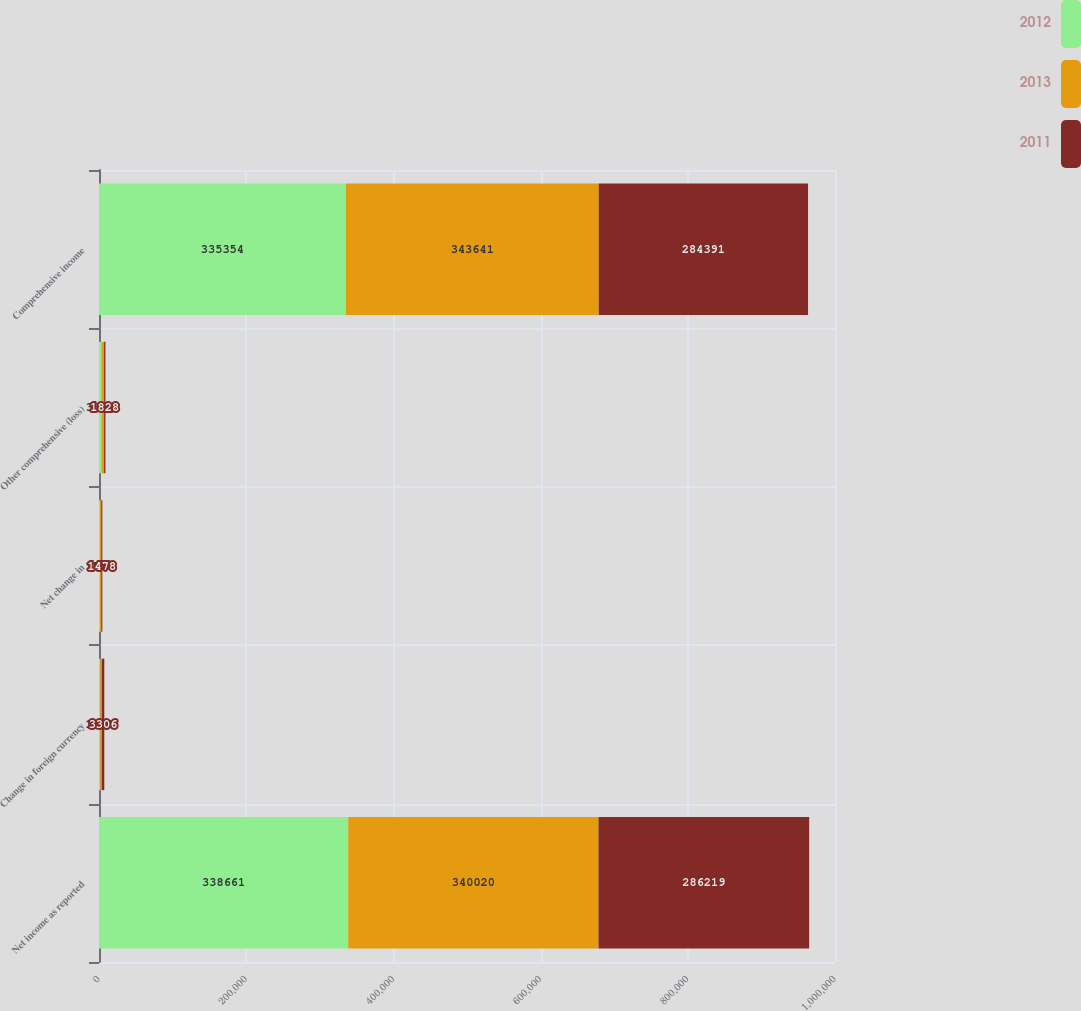Convert chart. <chart><loc_0><loc_0><loc_500><loc_500><stacked_bar_chart><ecel><fcel>Net income as reported<fcel>Change in foreign currency<fcel>Net change in<fcel>Other comprehensive (loss)<fcel>Comprehensive income<nl><fcel>2012<fcel>338661<fcel>1782<fcel>1525<fcel>3307<fcel>335354<nl><fcel>2013<fcel>340020<fcel>2096<fcel>1525<fcel>3621<fcel>343641<nl><fcel>2011<fcel>286219<fcel>3306<fcel>1478<fcel>1828<fcel>284391<nl></chart> 